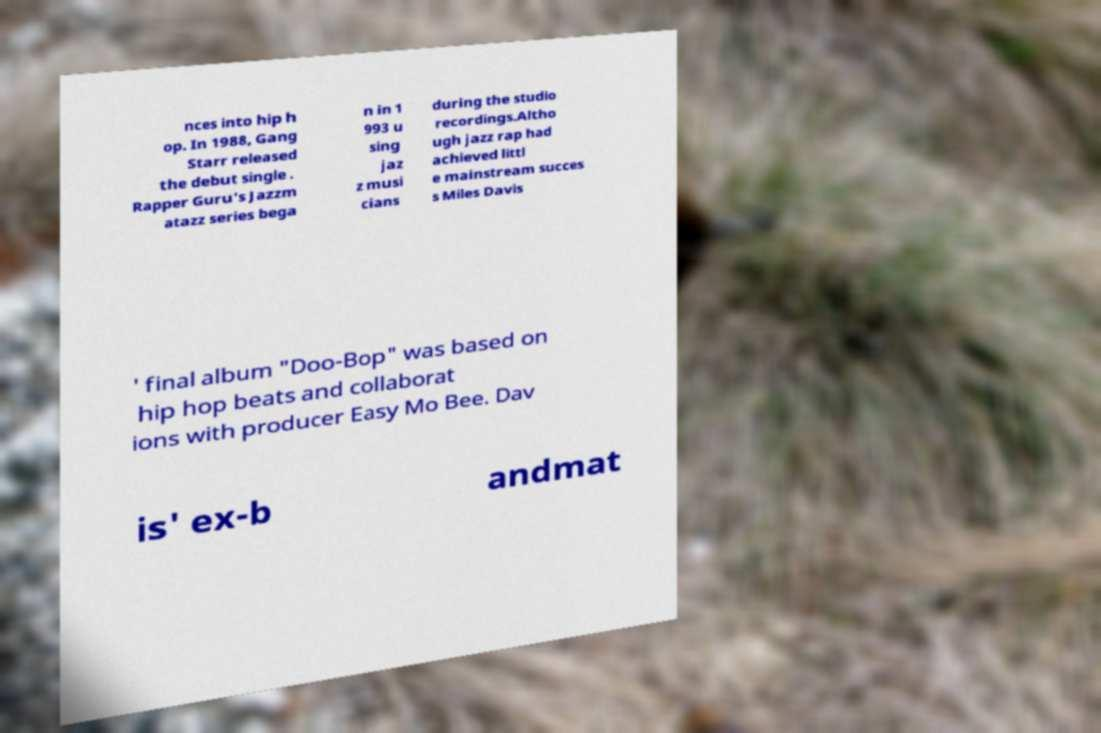I need the written content from this picture converted into text. Can you do that? nces into hip h op. In 1988, Gang Starr released the debut single . Rapper Guru's Jazzm atazz series bega n in 1 993 u sing jaz z musi cians during the studio recordings.Altho ugh jazz rap had achieved littl e mainstream succes s Miles Davis ' final album "Doo-Bop" was based on hip hop beats and collaborat ions with producer Easy Mo Bee. Dav is' ex-b andmat 